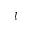Convert formula to latex. <formula><loc_0><loc_0><loc_500><loc_500>l</formula> 